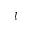Convert formula to latex. <formula><loc_0><loc_0><loc_500><loc_500>l</formula> 